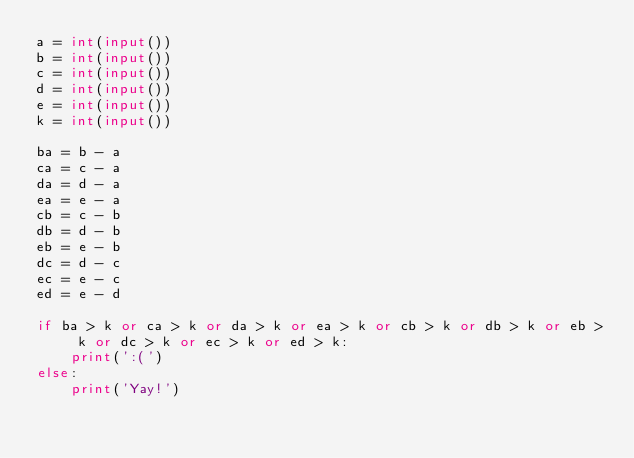Convert code to text. <code><loc_0><loc_0><loc_500><loc_500><_Python_>a = int(input())
b = int(input())
c = int(input())
d = int(input())
e = int(input())
k = int(input())

ba = b - a
ca = c - a
da = d - a
ea = e - a
cb = c - b
db = d - b
eb = e - b
dc = d - c
ec = e - c
ed = e - d

if ba > k or ca > k or da > k or ea > k or cb > k or db > k or eb > k or dc > k or ec > k or ed > k:
    print(':(')
else:
    print('Yay!')</code> 